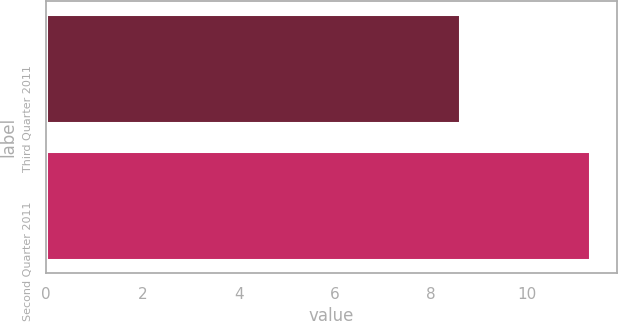Convert chart to OTSL. <chart><loc_0><loc_0><loc_500><loc_500><bar_chart><fcel>Third Quarter 2011<fcel>Second Quarter 2011<nl><fcel>8.6<fcel>11.3<nl></chart> 